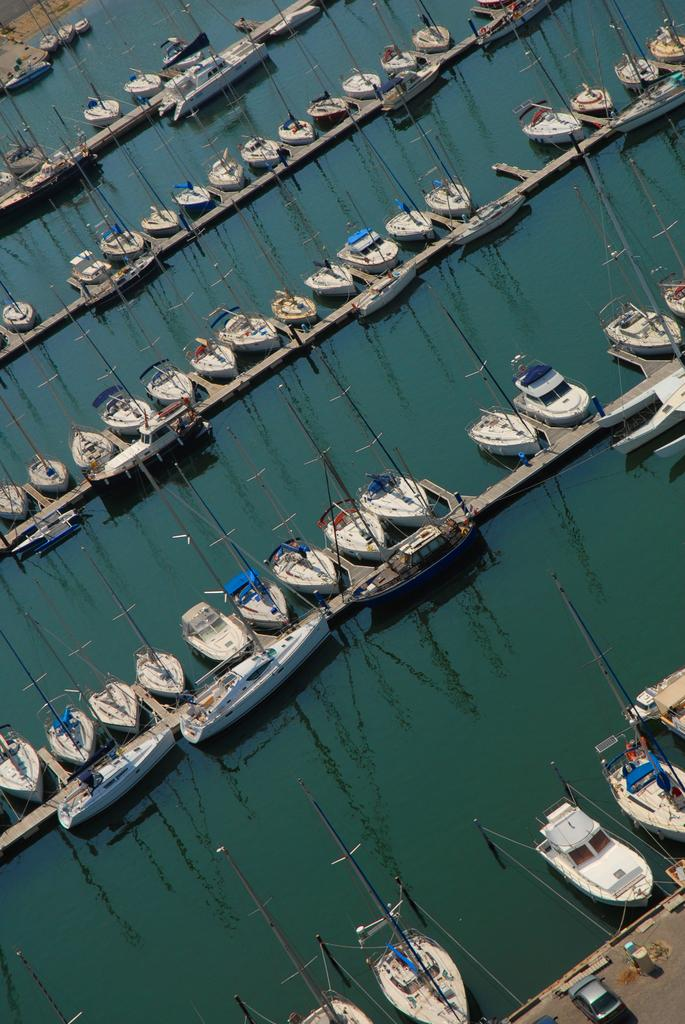What is positioned above the water in the image? There are boats above the water in the image. What type of structures can be seen in the image? There are bridges in the image. What objects are present in the image that are not related to water or transportation? There are poles in the image. What type of vehicle is visible in the image? There is a car in the image. Where is the plant located in the image? There is no plant present in the image. What is situated in the middle of the image? The provided facts do not specify any object or subject being in the middle of the image. What type of cub can be seen playing with the car in the image? There is no cub present in the image, and the car is not being played with. 